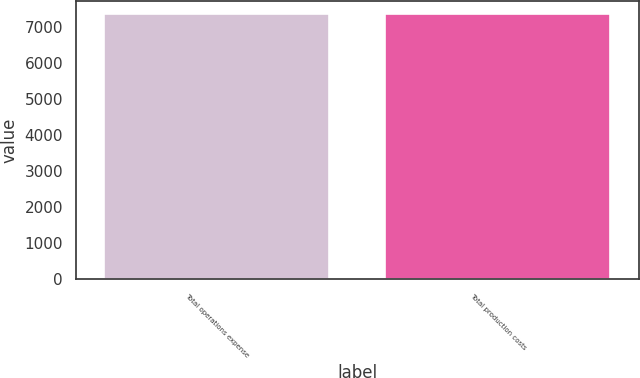Convert chart to OTSL. <chart><loc_0><loc_0><loc_500><loc_500><bar_chart><fcel>Total operations expense<fcel>Total production costs<nl><fcel>7366<fcel>7366.1<nl></chart> 